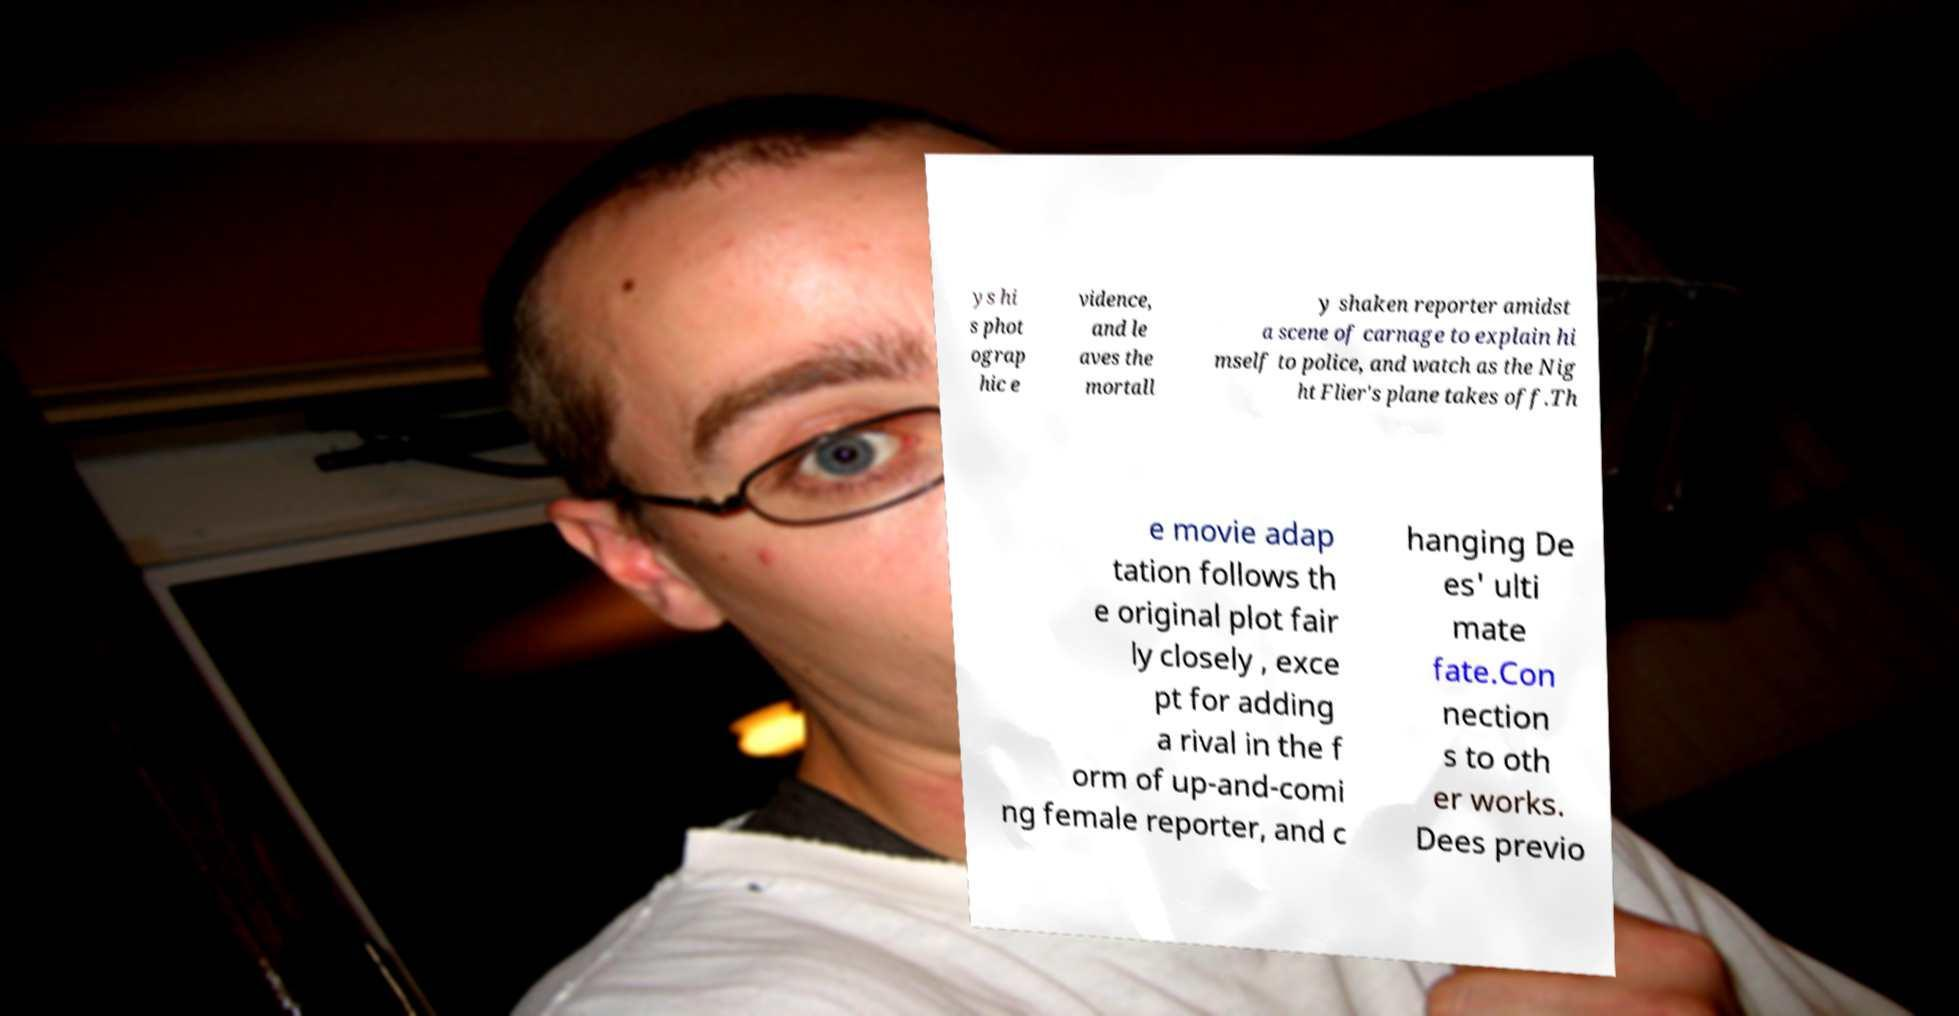Can you read and provide the text displayed in the image?This photo seems to have some interesting text. Can you extract and type it out for me? ys hi s phot ograp hic e vidence, and le aves the mortall y shaken reporter amidst a scene of carnage to explain hi mself to police, and watch as the Nig ht Flier's plane takes off.Th e movie adap tation follows th e original plot fair ly closely , exce pt for adding a rival in the f orm of up-and-comi ng female reporter, and c hanging De es' ulti mate fate.Con nection s to oth er works. Dees previo 